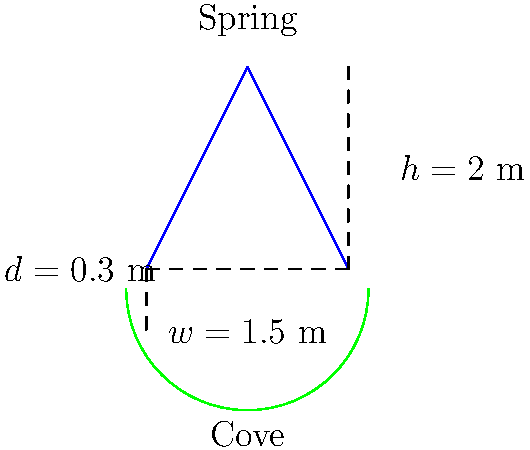While exploring a hidden cove in Ibiza, you discover a natural spring flowing into the sea. The spring forms a small stream with a width of 1.5 m and an average depth of 0.3 m. The water flows from a height of 2 m above sea level. Assuming the spring behaves like a rectangular weir, estimate the flow rate in cubic meters per second (m³/s) using the Francis formula: $Q = 1.84(L - 0.2H)H^{3/2}$, where $L$ is the width of the weir and $H$ is the head (height) of water above the weir crest. To estimate the flow rate using the Francis formula, we need to follow these steps:

1. Identify the given parameters:
   - Width of the stream (L) = 1.5 m
   - Height of the spring above sea level (H) = 2 m

2. Apply the Francis formula:
   $Q = 1.84(L - 0.2H)H^{3/2}$

3. Substitute the values:
   $Q = 1.84(1.5 - 0.2 \times 2) \times 2^{3/2}$

4. Simplify:
   $Q = 1.84(1.5 - 0.4) \times 2^{3/2}$
   $Q = 1.84 \times 1.1 \times 2^{3/2}$

5. Calculate:
   $Q = 1.84 \times 1.1 \times 2.83$
   $Q = 5.73$ m³/s

Therefore, the estimated flow rate of the natural spring is approximately 5.73 m³/s.
Answer: 5.73 m³/s 